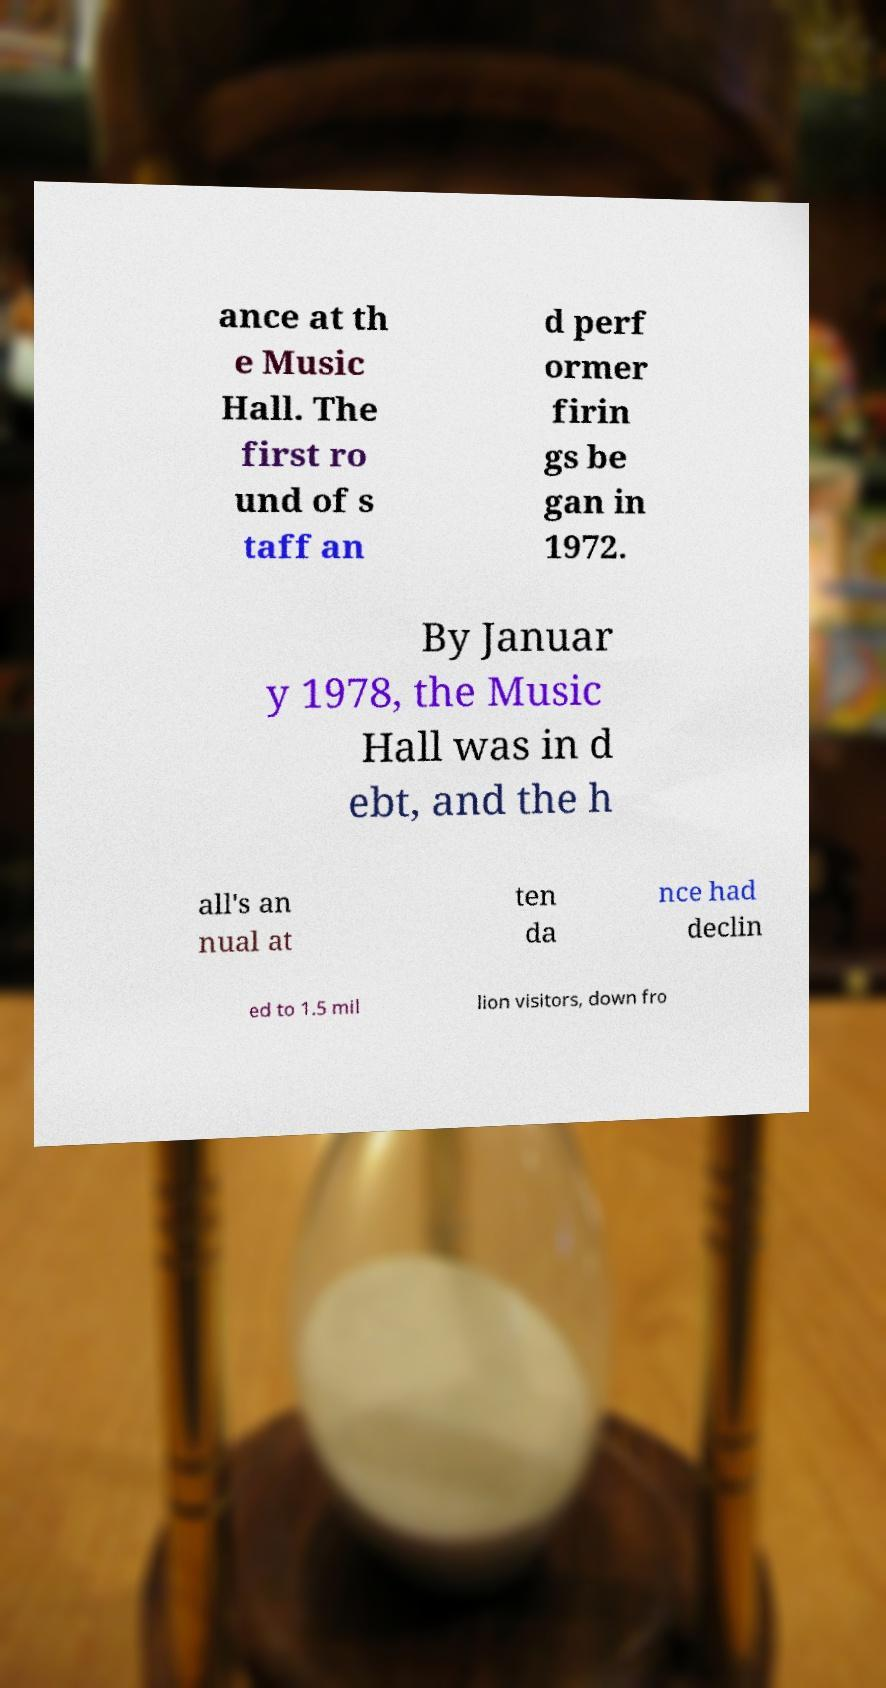Please identify and transcribe the text found in this image. ance at th e Music Hall. The first ro und of s taff an d perf ormer firin gs be gan in 1972. By Januar y 1978, the Music Hall was in d ebt, and the h all's an nual at ten da nce had declin ed to 1.5 mil lion visitors, down fro 